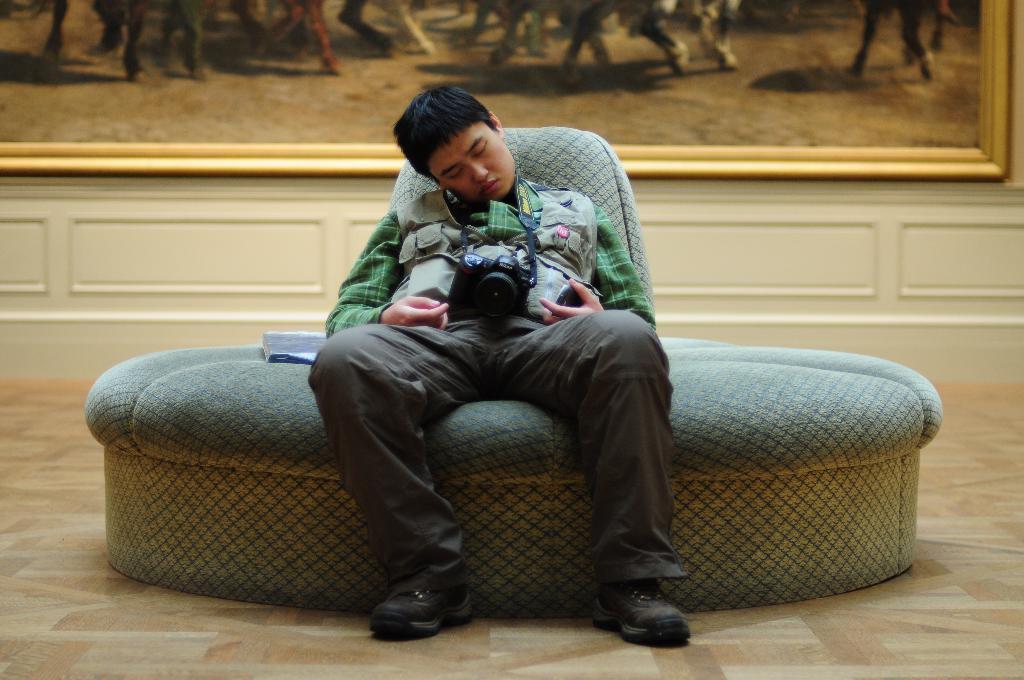Could you give a brief overview of what you see in this image? In this image I can see a person sitting on the sofa bed with closed eyes. He is wearing brown jacket and a camera. To the side there is a book on it. In the back there is a frame to the wall. 